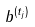Convert formula to latex. <formula><loc_0><loc_0><loc_500><loc_500>b ^ { ( t _ { j } ) }</formula> 